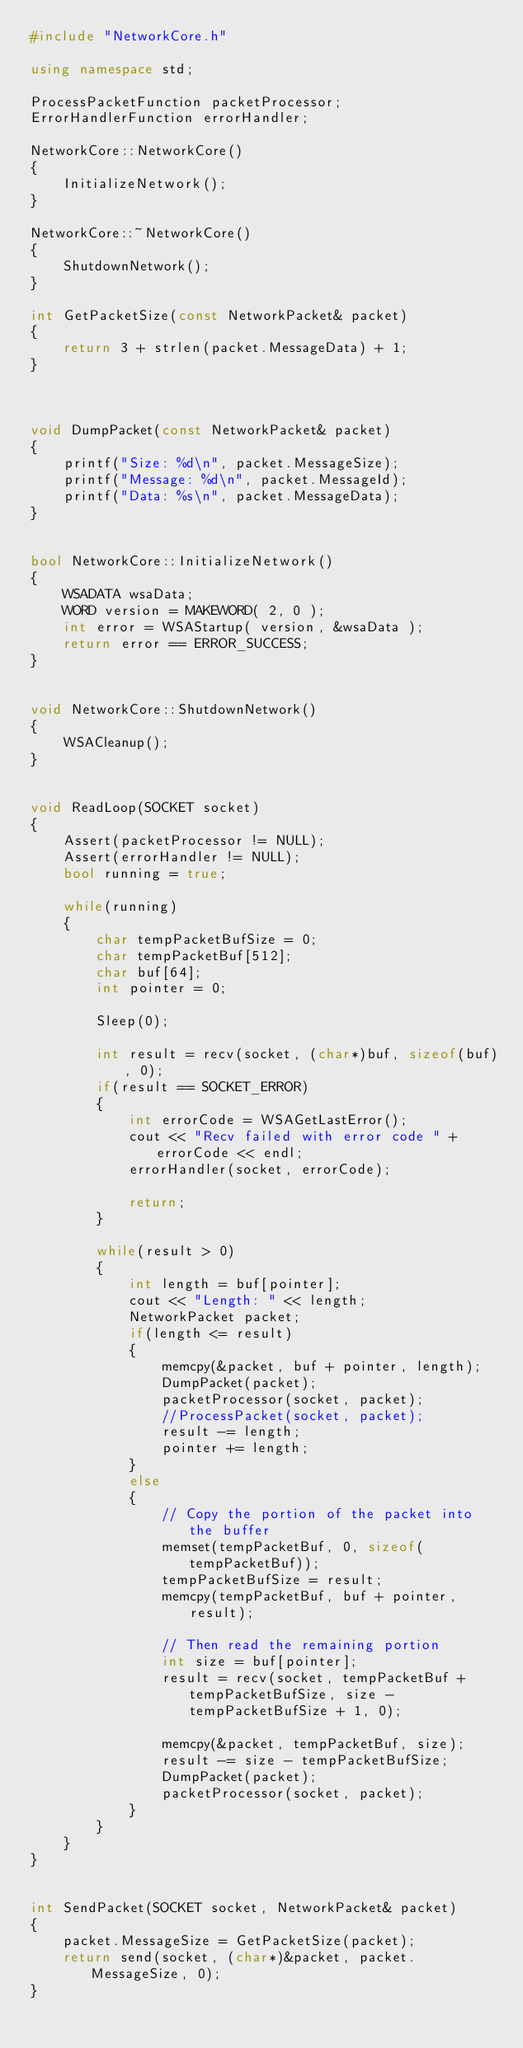<code> <loc_0><loc_0><loc_500><loc_500><_C++_>#include "NetworkCore.h"

using namespace std;

ProcessPacketFunction packetProcessor;
ErrorHandlerFunction errorHandler;

NetworkCore::NetworkCore()
{
	InitializeNetwork();
}

NetworkCore::~NetworkCore()
{
	ShutdownNetwork();
}

int GetPacketSize(const NetworkPacket& packet)
{
	return 3 + strlen(packet.MessageData) + 1;
}



void DumpPacket(const NetworkPacket& packet)
{
	printf("Size: %d\n", packet.MessageSize);
	printf("Message: %d\n", packet.MessageId);
	printf("Data: %s\n", packet.MessageData);
}


bool NetworkCore::InitializeNetwork()
{
	WSADATA wsaData;
	WORD version = MAKEWORD( 2, 0 );
	int error = WSAStartup( version, &wsaData );
	return error == ERROR_SUCCESS;
}


void NetworkCore::ShutdownNetwork()
{
	WSACleanup();
}


void ReadLoop(SOCKET socket)
{	
	Assert(packetProcessor != NULL);
	Assert(errorHandler != NULL);
	bool running = true;

	while(running)
	{
		char tempPacketBufSize = 0;
		char tempPacketBuf[512];
		char buf[64];
		int pointer = 0;

		Sleep(0);
		
		int result = recv(socket, (char*)buf, sizeof(buf), 0);
		if(result == SOCKET_ERROR)
		{
			int errorCode = WSAGetLastError();
			cout << "Recv failed with error code " + errorCode << endl;
			errorHandler(socket, errorCode);

			return;
		}

		while(result > 0)
		{
			int length = buf[pointer];
			cout << "Length: " << length;
			NetworkPacket packet;
			if(length <= result)
			{
				memcpy(&packet, buf + pointer, length);
				DumpPacket(packet);
				packetProcessor(socket, packet);
				//ProcessPacket(socket, packet);
				result -= length;
				pointer += length;
			}
			else
			{
				// Copy the portion of the packet into the buffer
				memset(tempPacketBuf, 0, sizeof(tempPacketBuf));
				tempPacketBufSize = result;
				memcpy(tempPacketBuf, buf + pointer, result);

				// Then read the remaining portion
				int size = buf[pointer];
				result = recv(socket, tempPacketBuf + tempPacketBufSize, size - tempPacketBufSize + 1, 0);
				
				memcpy(&packet, tempPacketBuf, size);
				result -= size - tempPacketBufSize;
				DumpPacket(packet);
				packetProcessor(socket, packet);
			}
		}
	}
}


int SendPacket(SOCKET socket, NetworkPacket& packet)
{
	packet.MessageSize = GetPacketSize(packet);
	return send(socket, (char*)&packet, packet.MessageSize, 0);
}</code> 